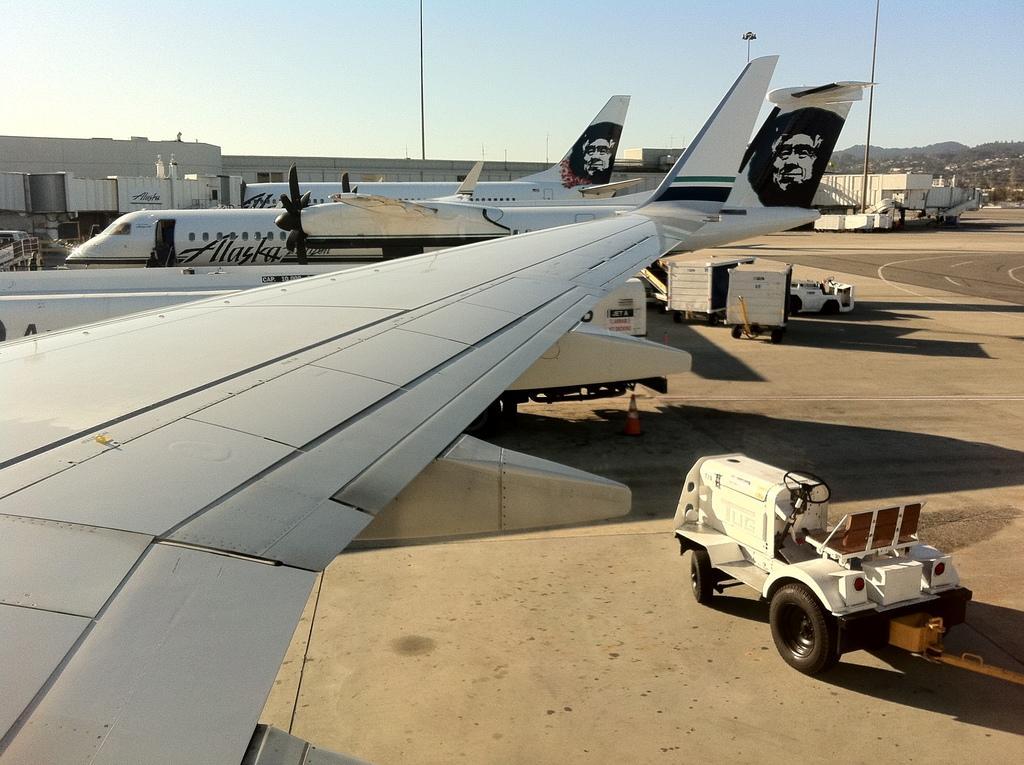Could you give a brief overview of what you see in this image? In this image there are many aeroplanes in the runway, beside them there is a luggage vehicle, also there are so many mountains at there back. 